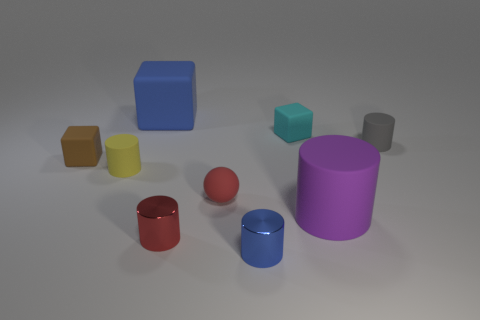Subtract all purple cylinders. How many cylinders are left? 4 Subtract all yellow cylinders. How many cylinders are left? 4 Subtract all green cylinders. Subtract all green spheres. How many cylinders are left? 5 Add 1 tiny green rubber objects. How many objects exist? 10 Subtract all cubes. How many objects are left? 6 Subtract all tiny red rubber objects. Subtract all yellow things. How many objects are left? 7 Add 8 small yellow objects. How many small yellow objects are left? 9 Add 4 cyan objects. How many cyan objects exist? 5 Subtract 0 green cubes. How many objects are left? 9 